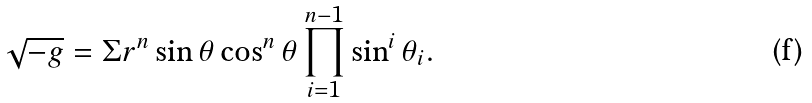Convert formula to latex. <formula><loc_0><loc_0><loc_500><loc_500>\sqrt { - g } = \Sigma r ^ { n } \sin \theta \cos ^ { n } \theta \prod _ { i = 1 } ^ { n - 1 } \sin ^ { i } \theta _ { i } .</formula> 